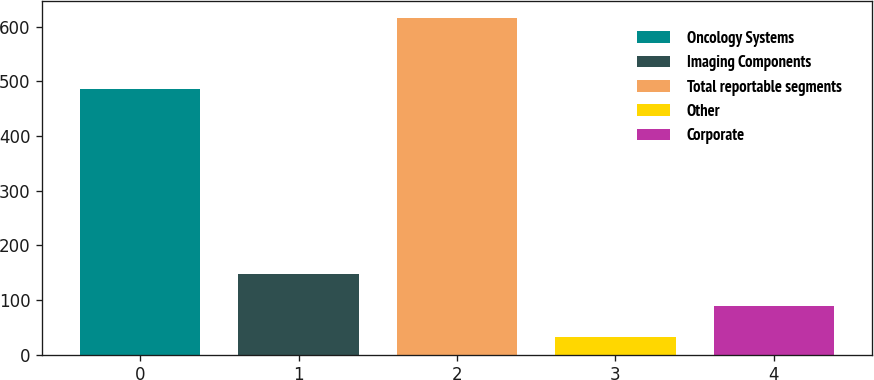Convert chart to OTSL. <chart><loc_0><loc_0><loc_500><loc_500><bar_chart><fcel>Oncology Systems<fcel>Imaging Components<fcel>Total reportable segments<fcel>Other<fcel>Corporate<nl><fcel>485.4<fcel>148.3<fcel>616.7<fcel>31.2<fcel>89.75<nl></chart> 